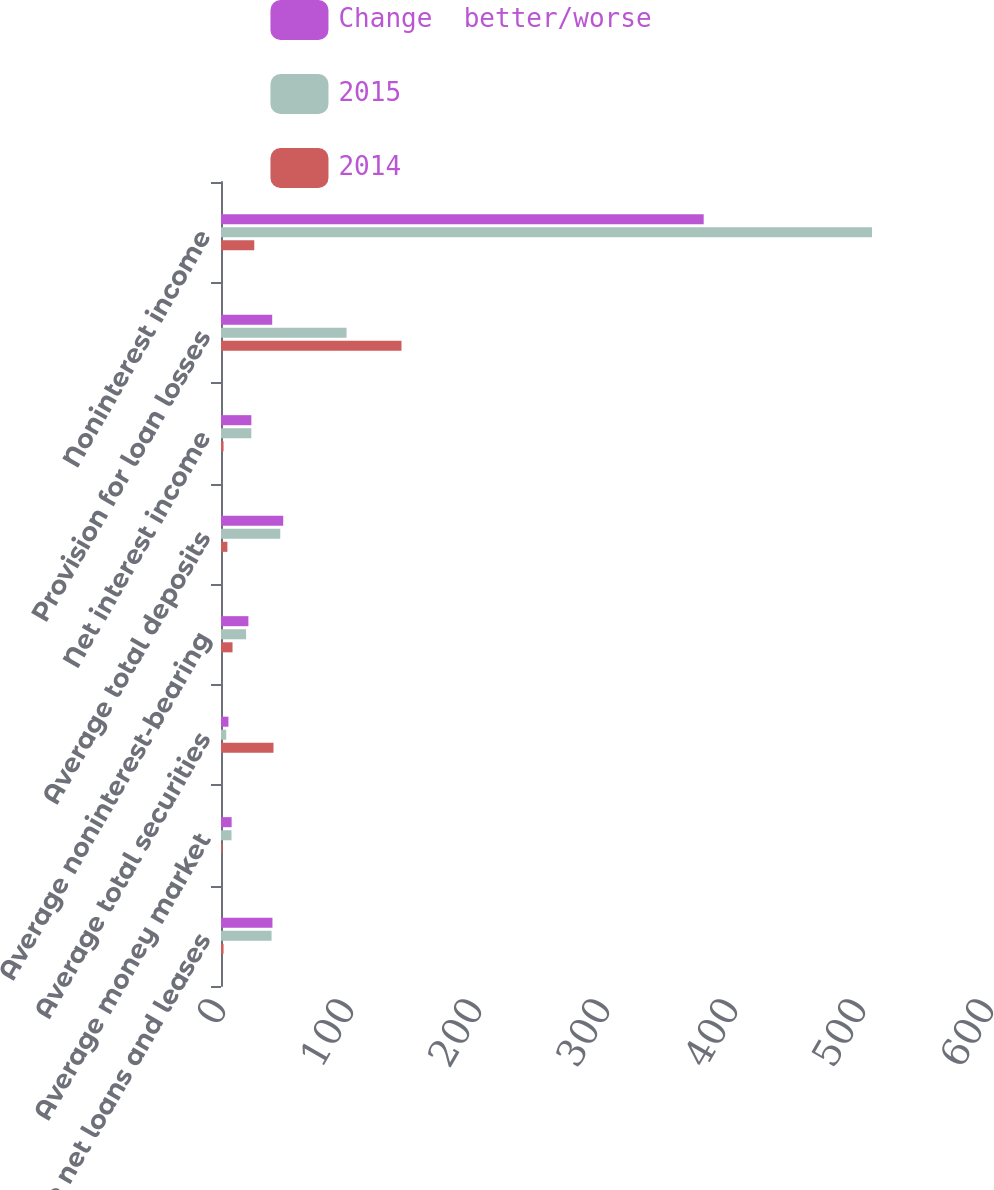Convert chart. <chart><loc_0><loc_0><loc_500><loc_500><stacked_bar_chart><ecel><fcel>Average net loans and leases<fcel>Average money market<fcel>Average total securities<fcel>Average noninterest-bearing<fcel>Average total deposits<fcel>Net interest income<fcel>Provision for loan losses<fcel>Noninterest income<nl><fcel>Change  better/worse<fcel>40.2<fcel>8.3<fcel>5.8<fcel>21.4<fcel>48.6<fcel>23.7<fcel>40<fcel>377.1<nl><fcel>2015<fcel>39.5<fcel>8.2<fcel>4.1<fcel>19.6<fcel>46.3<fcel>23.7<fcel>98.1<fcel>508.6<nl><fcel>2014<fcel>2<fcel>1<fcel>41<fcel>9<fcel>5<fcel>2<fcel>141<fcel>26<nl></chart> 